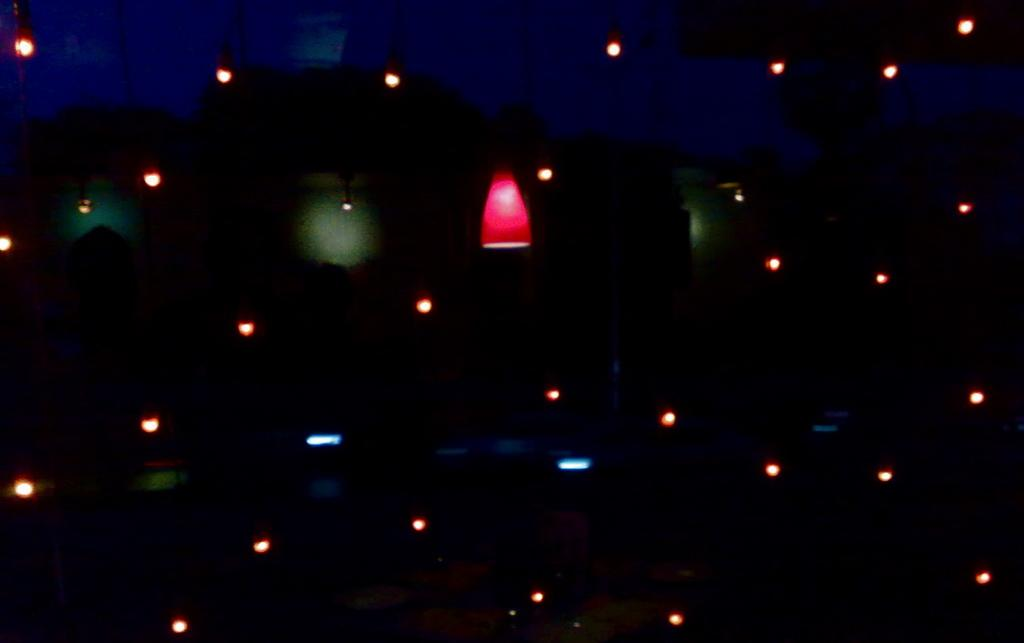What is present in the image that provides illumination? There are lights in the image. What type of root can be seen growing from the lights in the image? There is no root growing from the lights in the image. What type of cub is visible in the image? There is no cub present in the image. 